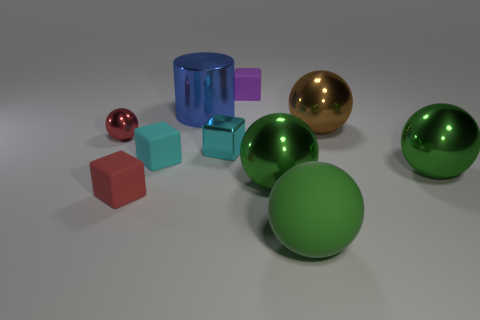Can you describe the colors and materials of the objects in this image? Certainly! In this image, there is a diverse collection of objects featuring a variety of colors and materials. Starting with colors, there are objects in shades of red, blue, purple, green, and a golden brown. The materials seem to emulate rubber and metal surfaces. Specifically, the two spheres and a cube appear to have a rubbery texture, with colors in green and purple. The cubic object has a translucent blue color that suggests a glass-like material. Lastly, there is a shiny, golden brown sphere that gives the impression of a polished metallic surface.  How do the objects' positions relate to each other? The objects are arranged in a somewhat scattered manner across the surface. To the foreground, there's a large green rubber sphere with a smaller green sphere and a purple cube closely positioned in front of the big brown metallic sphere. To the right of the purple rubber cube, there's a tiny shiny sphere. Above all, the spatial layout gives a sense of casual placement, perhaps suggestive of a playful or artistic setting. 